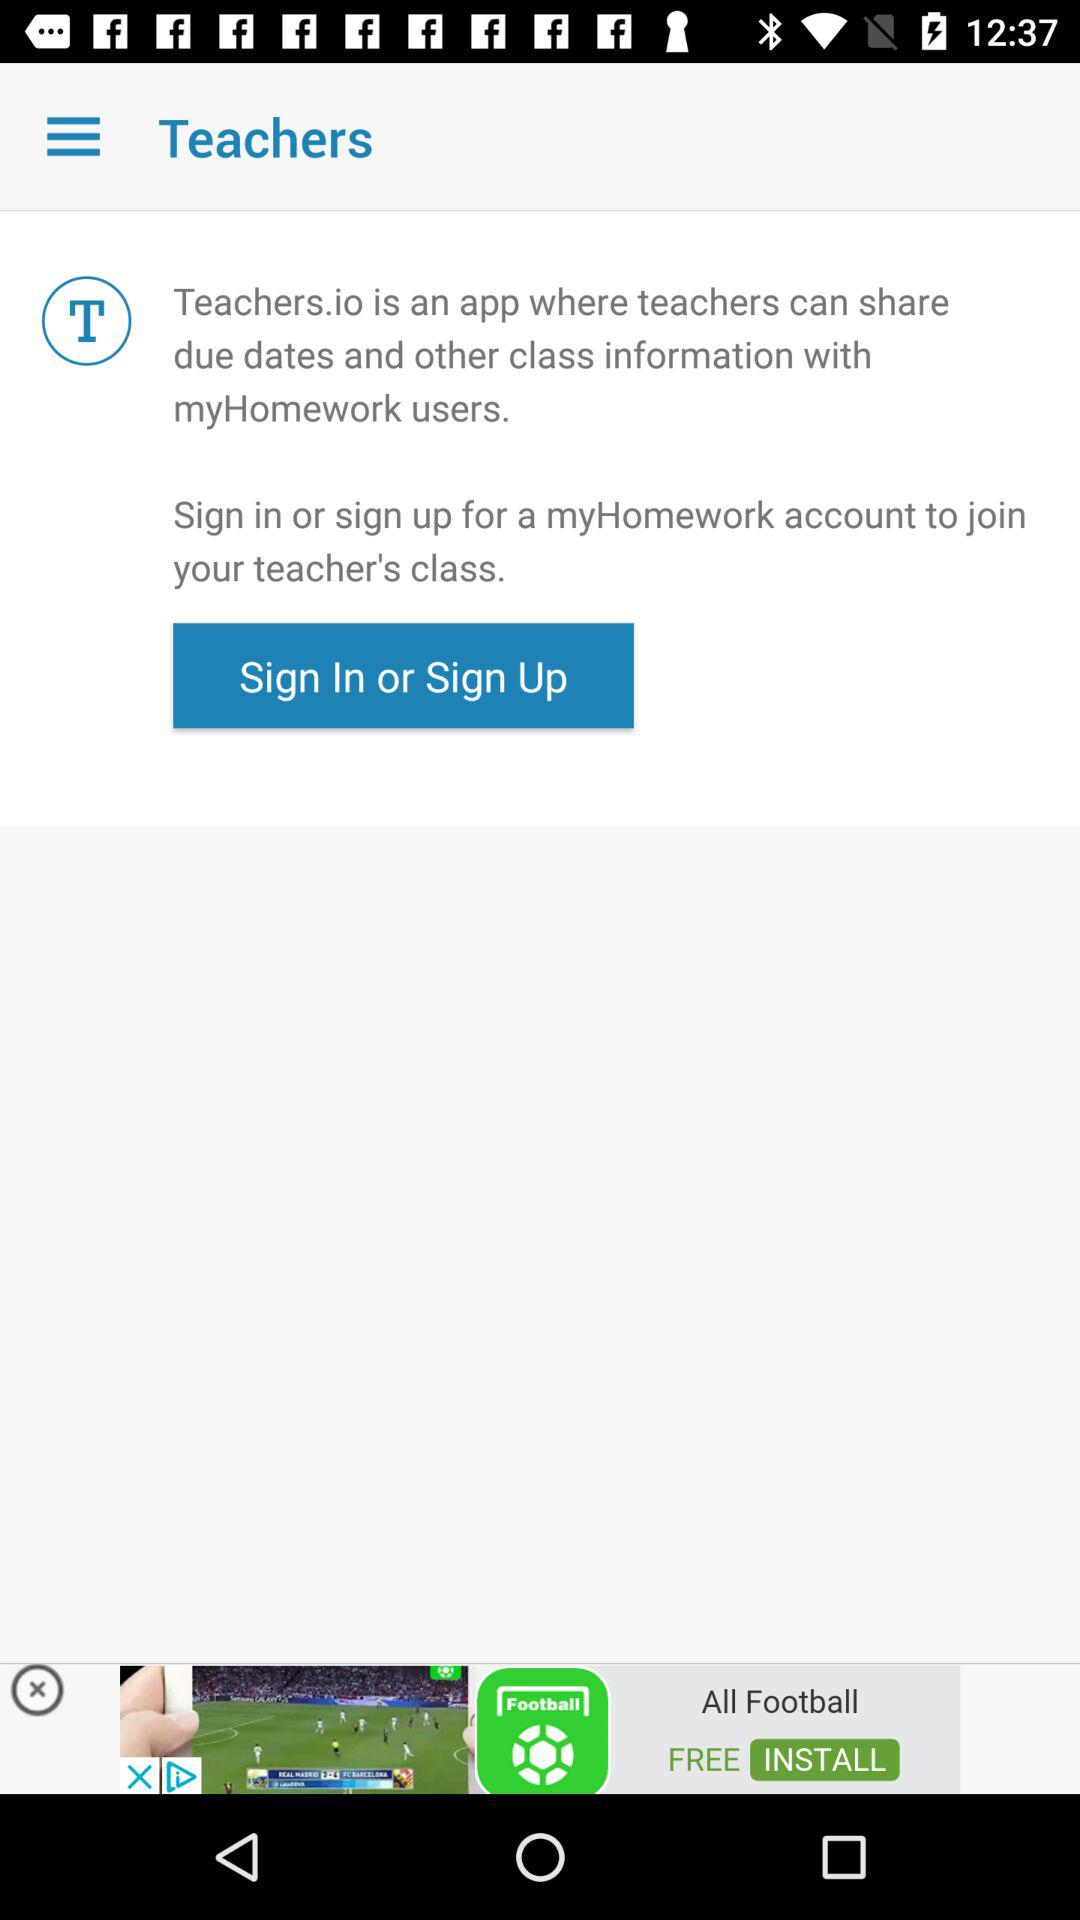What account should we sign in with to join our teacher's class? You should sign in with your "myHomework" account. 